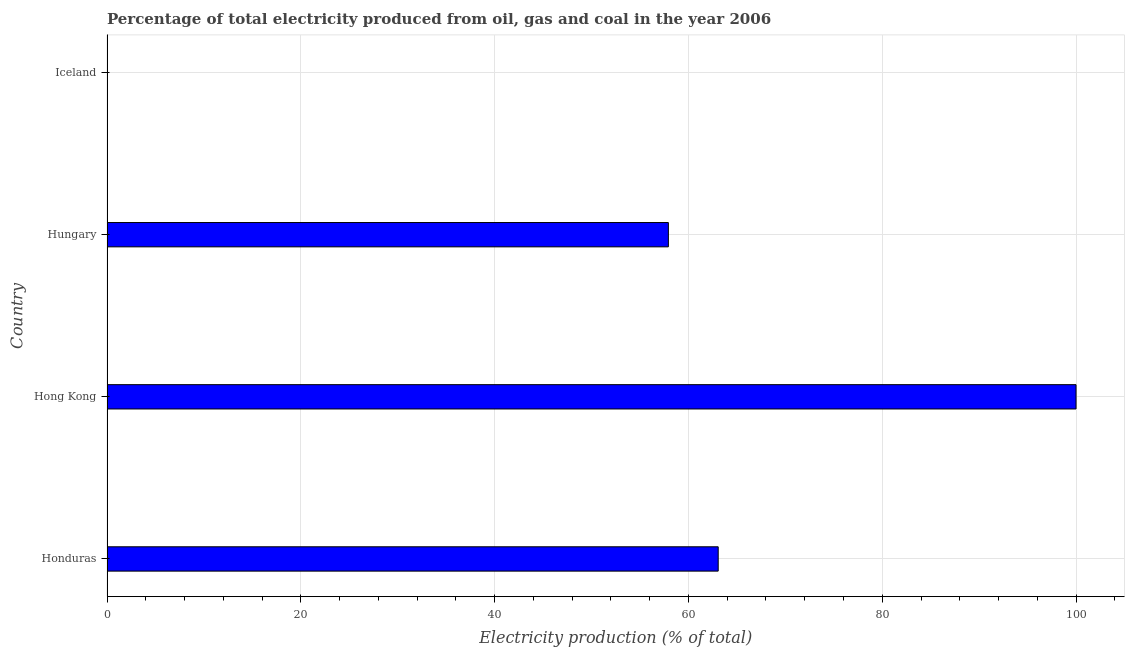Does the graph contain grids?
Make the answer very short. Yes. What is the title of the graph?
Offer a very short reply. Percentage of total electricity produced from oil, gas and coal in the year 2006. What is the label or title of the X-axis?
Give a very brief answer. Electricity production (% of total). What is the electricity production in Iceland?
Give a very brief answer. 0.04. Across all countries, what is the maximum electricity production?
Provide a succinct answer. 100. Across all countries, what is the minimum electricity production?
Ensure brevity in your answer.  0.04. In which country was the electricity production maximum?
Make the answer very short. Hong Kong. What is the sum of the electricity production?
Provide a short and direct response. 221.04. What is the difference between the electricity production in Hong Kong and Iceland?
Make the answer very short. 99.96. What is the average electricity production per country?
Give a very brief answer. 55.26. What is the median electricity production?
Offer a terse response. 60.5. What is the ratio of the electricity production in Honduras to that in Iceland?
Offer a terse response. 1565.76. What is the difference between the highest and the second highest electricity production?
Provide a succinct answer. 36.93. Is the sum of the electricity production in Hong Kong and Hungary greater than the maximum electricity production across all countries?
Your answer should be compact. Yes. What is the difference between the highest and the lowest electricity production?
Offer a very short reply. 99.96. In how many countries, is the electricity production greater than the average electricity production taken over all countries?
Provide a short and direct response. 3. How many bars are there?
Your answer should be very brief. 4. Are all the bars in the graph horizontal?
Your response must be concise. Yes. How many countries are there in the graph?
Ensure brevity in your answer.  4. What is the difference between two consecutive major ticks on the X-axis?
Your answer should be compact. 20. What is the Electricity production (% of total) of Honduras?
Make the answer very short. 63.07. What is the Electricity production (% of total) in Hong Kong?
Your answer should be compact. 100. What is the Electricity production (% of total) in Hungary?
Offer a terse response. 57.93. What is the Electricity production (% of total) in Iceland?
Your response must be concise. 0.04. What is the difference between the Electricity production (% of total) in Honduras and Hong Kong?
Give a very brief answer. -36.93. What is the difference between the Electricity production (% of total) in Honduras and Hungary?
Your response must be concise. 5.14. What is the difference between the Electricity production (% of total) in Honduras and Iceland?
Give a very brief answer. 63.03. What is the difference between the Electricity production (% of total) in Hong Kong and Hungary?
Provide a succinct answer. 42.07. What is the difference between the Electricity production (% of total) in Hong Kong and Iceland?
Make the answer very short. 99.96. What is the difference between the Electricity production (% of total) in Hungary and Iceland?
Make the answer very short. 57.89. What is the ratio of the Electricity production (% of total) in Honduras to that in Hong Kong?
Ensure brevity in your answer.  0.63. What is the ratio of the Electricity production (% of total) in Honduras to that in Hungary?
Give a very brief answer. 1.09. What is the ratio of the Electricity production (% of total) in Honduras to that in Iceland?
Provide a succinct answer. 1565.76. What is the ratio of the Electricity production (% of total) in Hong Kong to that in Hungary?
Ensure brevity in your answer.  1.73. What is the ratio of the Electricity production (% of total) in Hong Kong to that in Iceland?
Provide a succinct answer. 2482.44. What is the ratio of the Electricity production (% of total) in Hungary to that in Iceland?
Give a very brief answer. 1438.1. 